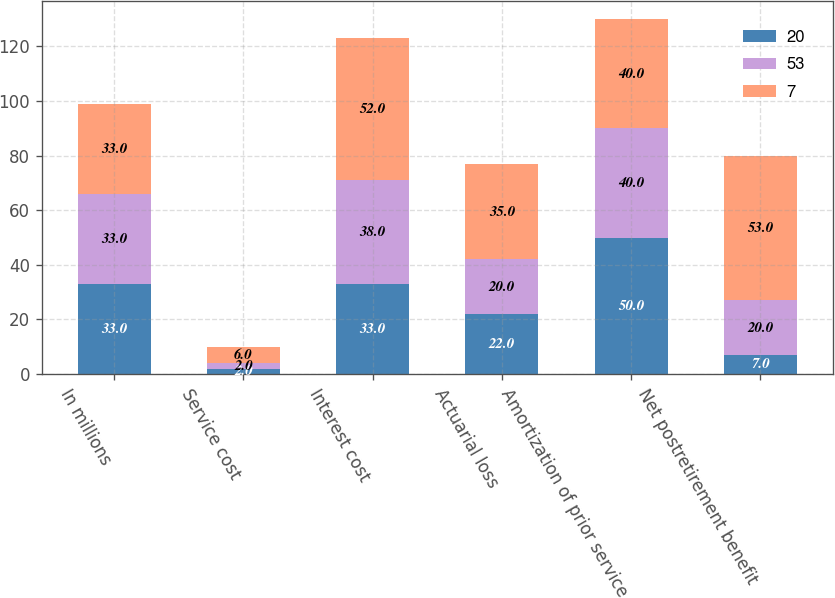Convert chart. <chart><loc_0><loc_0><loc_500><loc_500><stacked_bar_chart><ecel><fcel>In millions<fcel>Service cost<fcel>Interest cost<fcel>Actuarial loss<fcel>Amortization of prior service<fcel>Net postretirement benefit<nl><fcel>20<fcel>33<fcel>2<fcel>33<fcel>22<fcel>50<fcel>7<nl><fcel>53<fcel>33<fcel>2<fcel>38<fcel>20<fcel>40<fcel>20<nl><fcel>7<fcel>33<fcel>6<fcel>52<fcel>35<fcel>40<fcel>53<nl></chart> 